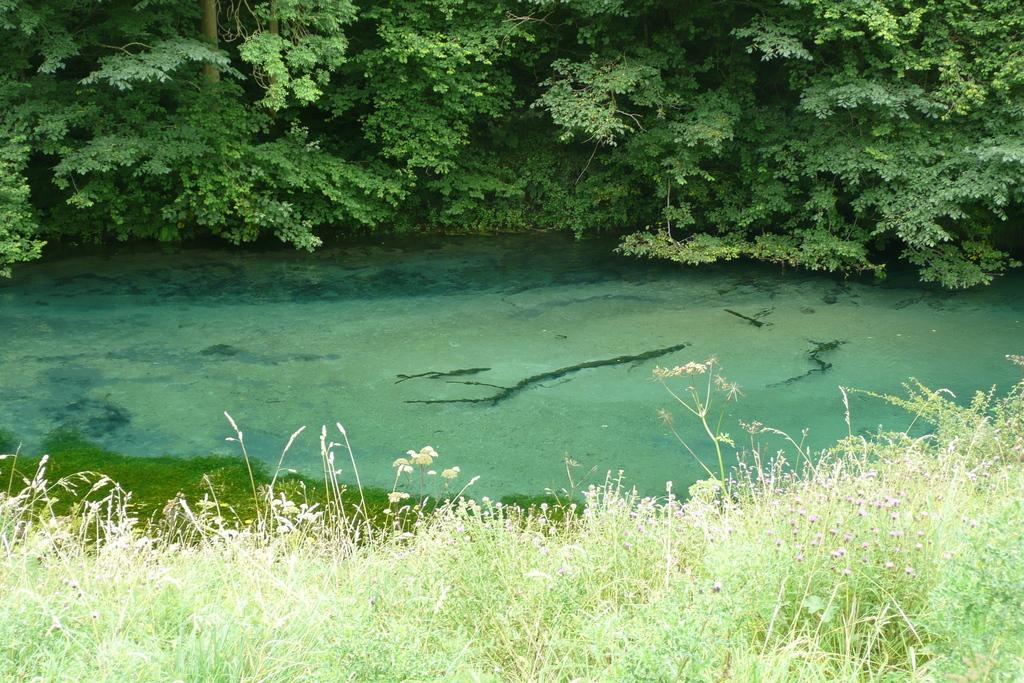What type of vegetation can be seen in the image? There are plants and trees visible in the image. What type of ground cover is present in the image? There is grass in the image. What natural element can be seen in the image? There is water visible in the image. Where is the faucet located in the image? There is no faucet present in the image. How many boys are playing with the plants in the image? There are no boys present in the image. 